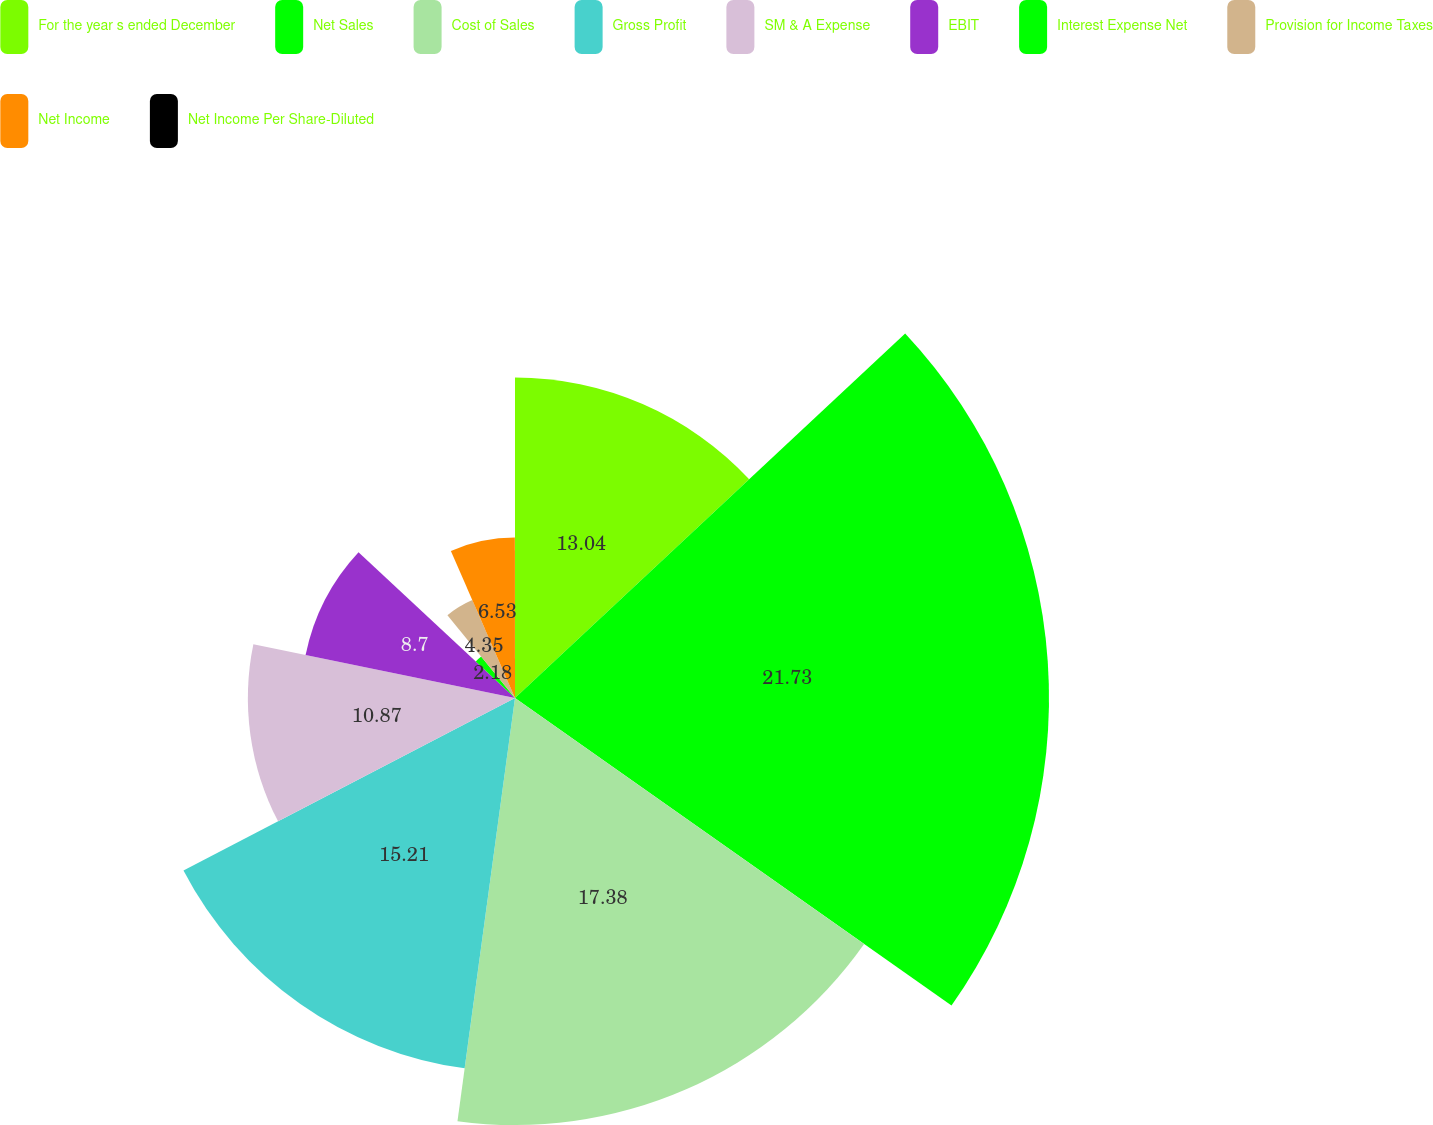Convert chart. <chart><loc_0><loc_0><loc_500><loc_500><pie_chart><fcel>For the year s ended December<fcel>Net Sales<fcel>Cost of Sales<fcel>Gross Profit<fcel>SM & A Expense<fcel>EBIT<fcel>Interest Expense Net<fcel>Provision for Income Taxes<fcel>Net Income<fcel>Net Income Per Share-Diluted<nl><fcel>13.04%<fcel>21.73%<fcel>17.38%<fcel>15.21%<fcel>10.87%<fcel>8.7%<fcel>2.18%<fcel>4.35%<fcel>6.53%<fcel>0.01%<nl></chart> 